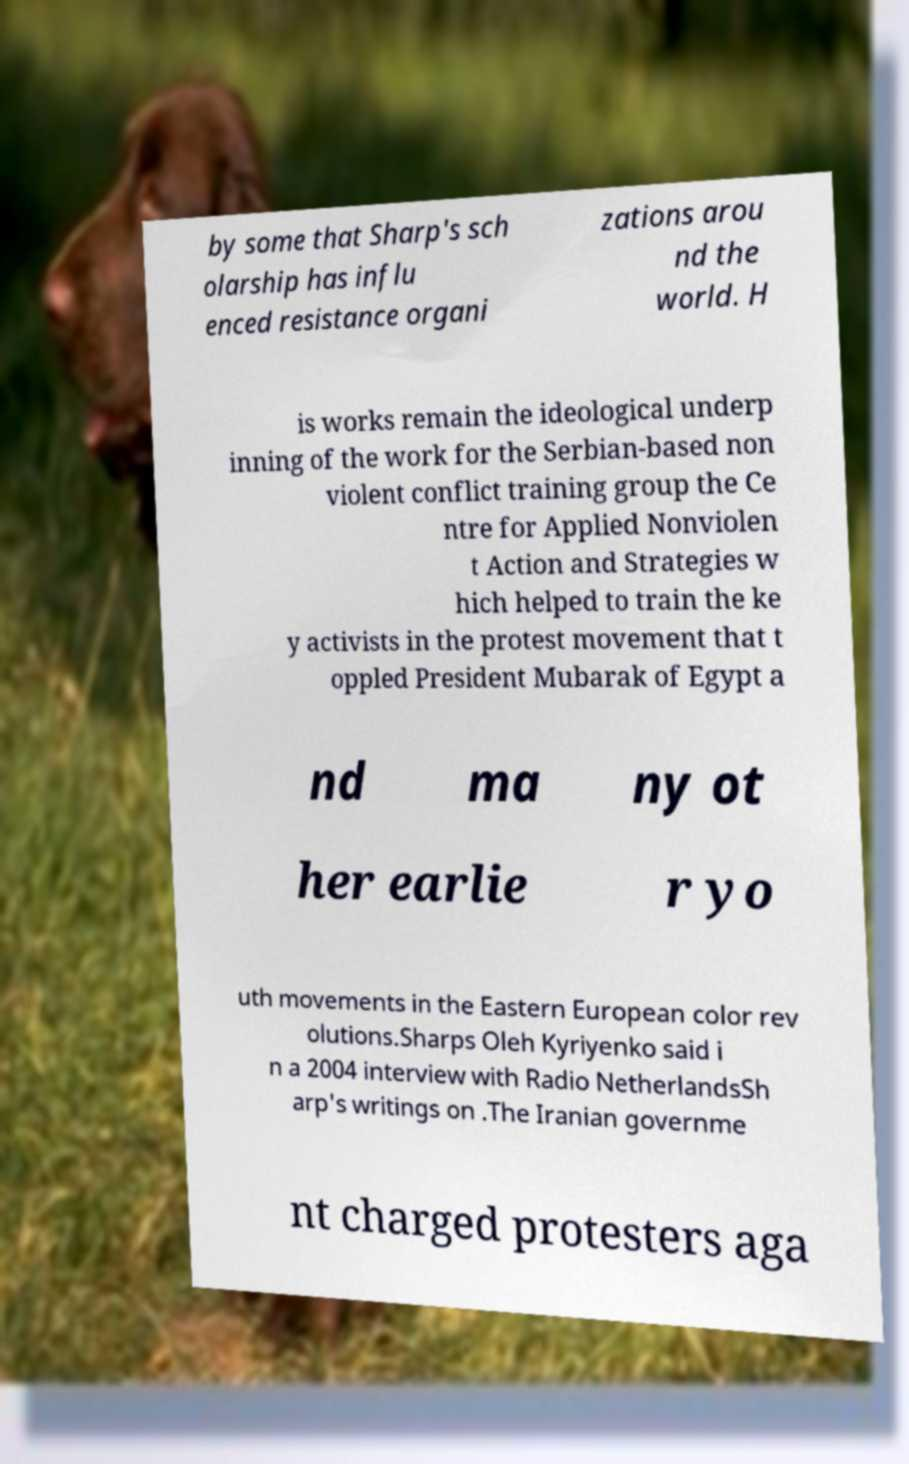Could you assist in decoding the text presented in this image and type it out clearly? by some that Sharp's sch olarship has influ enced resistance organi zations arou nd the world. H is works remain the ideological underp inning of the work for the Serbian-based non violent conflict training group the Ce ntre for Applied Nonviolen t Action and Strategies w hich helped to train the ke y activists in the protest movement that t oppled President Mubarak of Egypt a nd ma ny ot her earlie r yo uth movements in the Eastern European color rev olutions.Sharps Oleh Kyriyenko said i n a 2004 interview with Radio NetherlandsSh arp's writings on .The Iranian governme nt charged protesters aga 